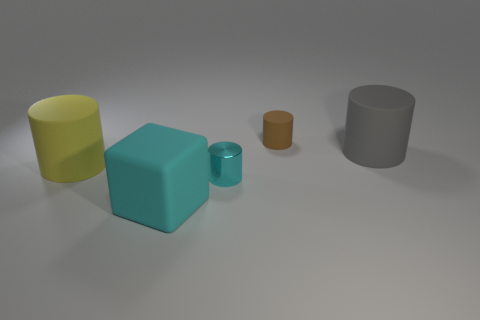Add 1 large green objects. How many objects exist? 6 Subtract all cylinders. How many objects are left? 1 Add 4 big blocks. How many big blocks exist? 5 Subtract 0 purple cylinders. How many objects are left? 5 Subtract all small cyan balls. Subtract all tiny brown matte objects. How many objects are left? 4 Add 2 rubber blocks. How many rubber blocks are left? 3 